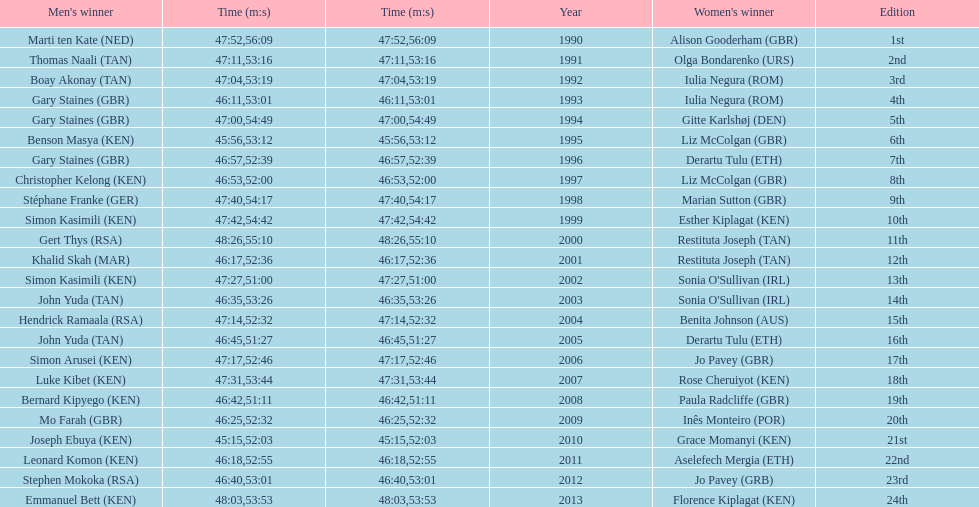The other women's winner with the same finish time as jo pavey in 2012 Iulia Negura. 